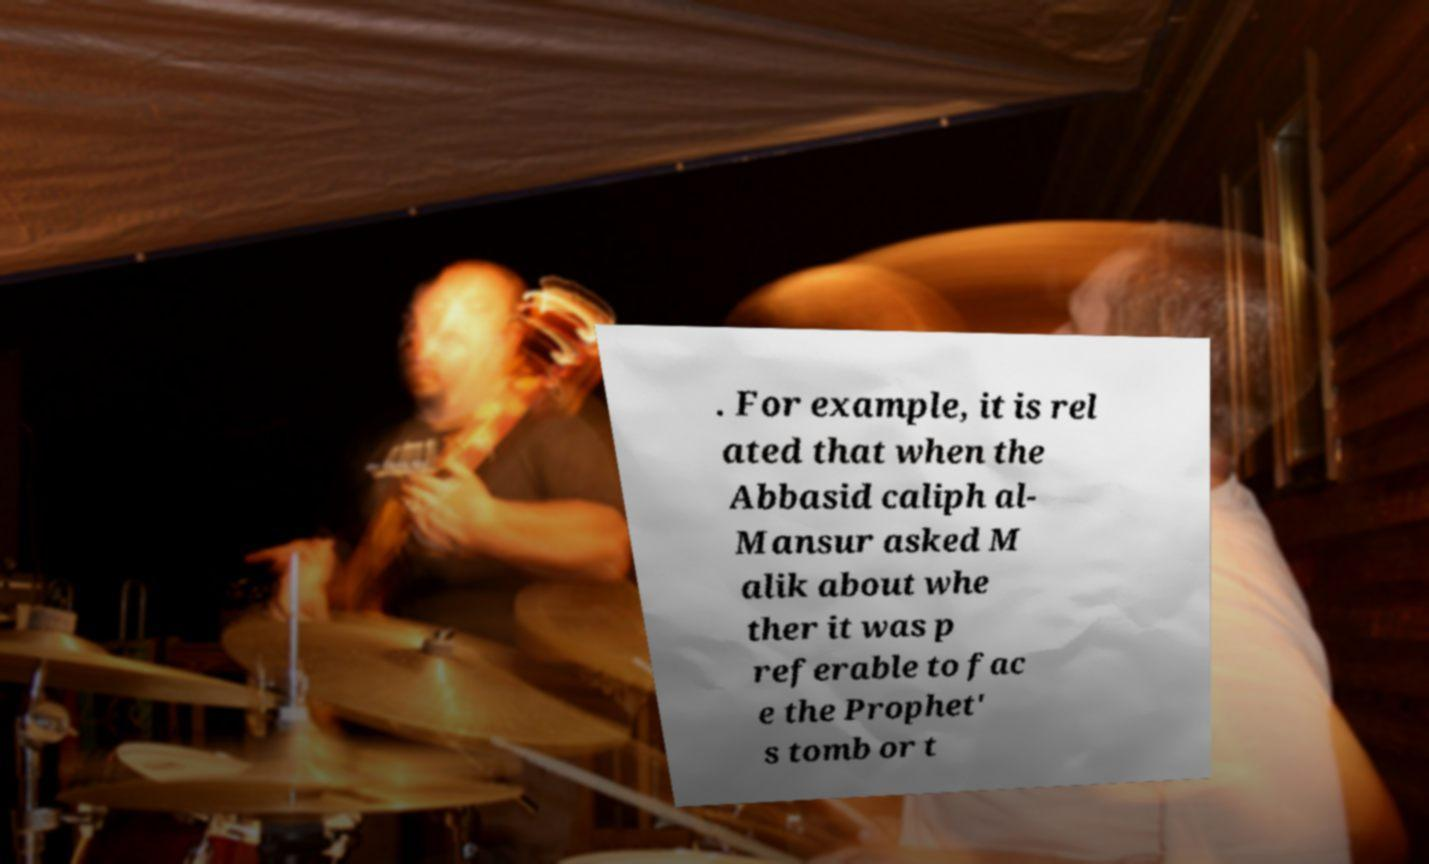There's text embedded in this image that I need extracted. Can you transcribe it verbatim? . For example, it is rel ated that when the Abbasid caliph al- Mansur asked M alik about whe ther it was p referable to fac e the Prophet' s tomb or t 